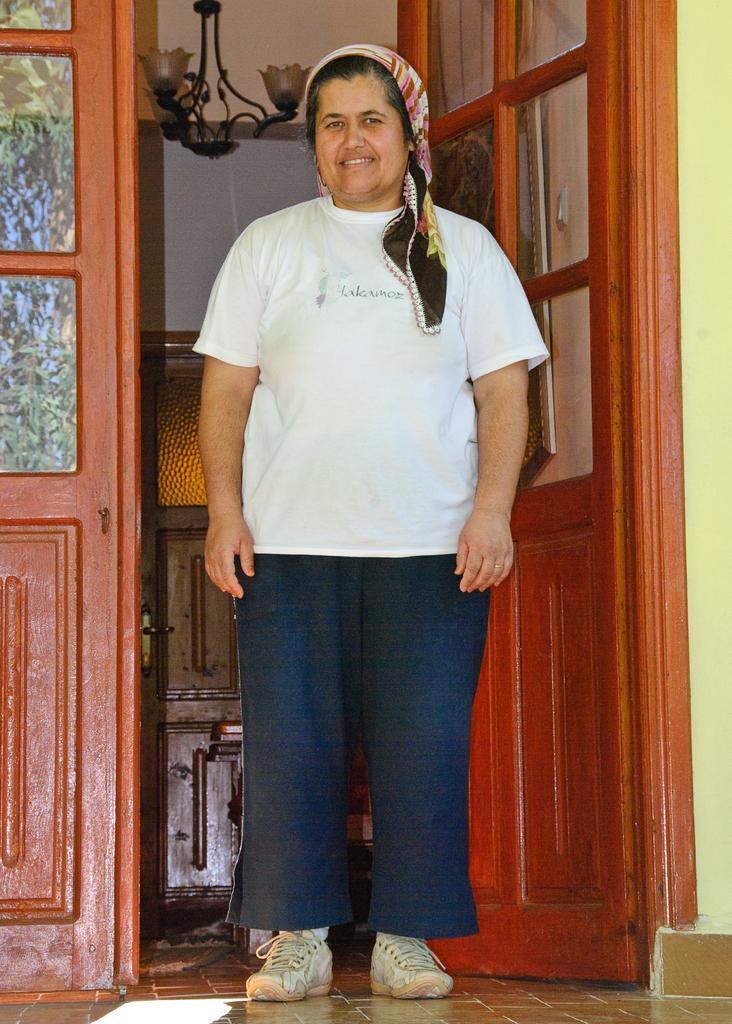Can you describe this image briefly? In this image we can see a person. There is a door in the image. We can see some reflections on the glasses at the left side of the image. There are few lamps in the image. 